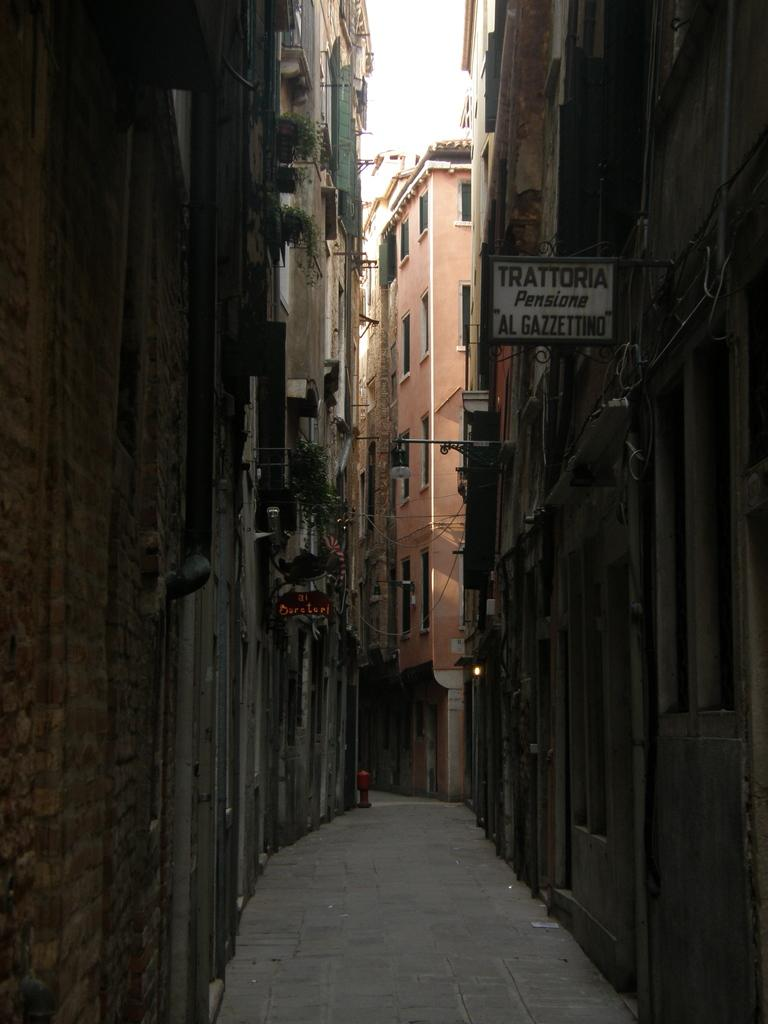What can be seen running through the image? There is a path in the image. What type of structures are present in the image? There are buildings in the image. What feature do the buildings have? The buildings have windows. What type of signage is visible in the image? There are posters in the image. What type of vertical structures are present in the image? There are poles in the image. What type of natural elements are present in the image? There are plants in the image. What part of the natural environment is visible in the image? The sky is visible in the image. What type of print can be seen on the breakfast in the image? There is no breakfast present in the image, so it is not possible to determine if there is any print on it. 